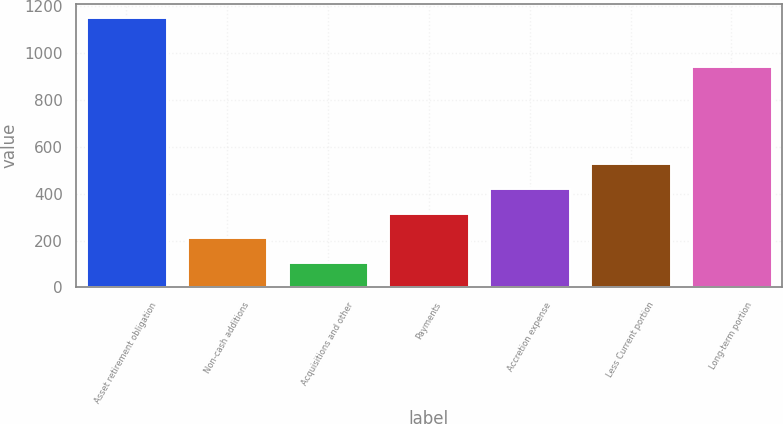Convert chart. <chart><loc_0><loc_0><loc_500><loc_500><bar_chart><fcel>Asset retirement obligation<fcel>Non-cash additions<fcel>Acquisitions and other<fcel>Payments<fcel>Accretion expense<fcel>Less Current portion<fcel>Long-term portion<nl><fcel>1151.56<fcel>214.16<fcel>109.38<fcel>318.94<fcel>423.72<fcel>528.5<fcel>942<nl></chart> 